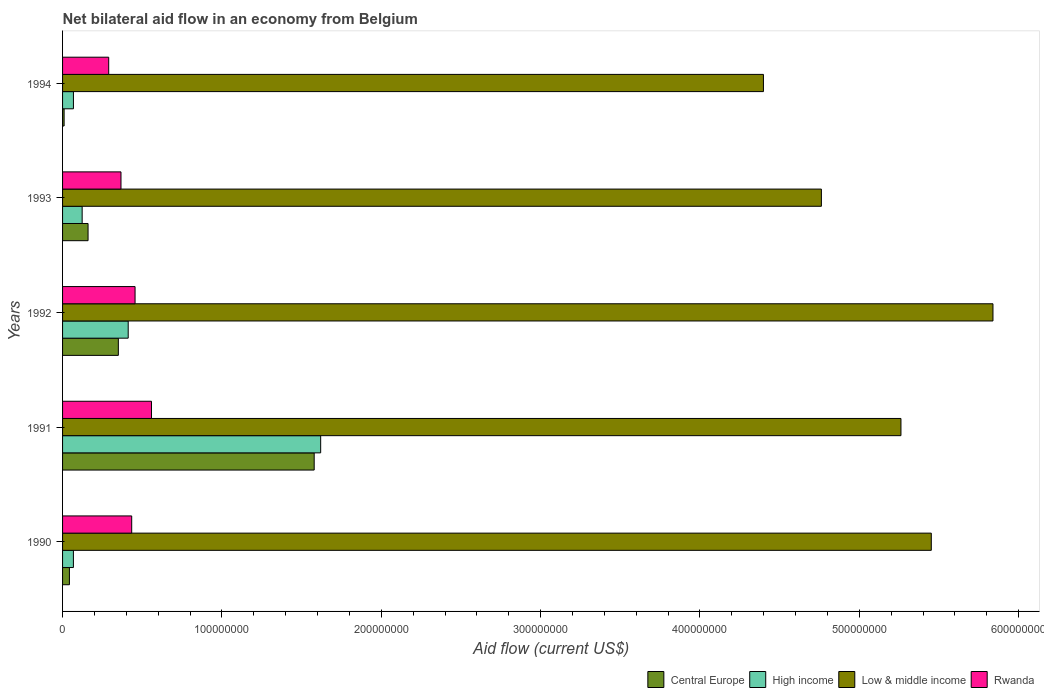How many different coloured bars are there?
Your answer should be very brief. 4. How many groups of bars are there?
Provide a short and direct response. 5. Are the number of bars on each tick of the Y-axis equal?
Your answer should be very brief. Yes. In how many cases, is the number of bars for a given year not equal to the number of legend labels?
Ensure brevity in your answer.  0. What is the net bilateral aid flow in Central Europe in 1990?
Your answer should be compact. 4.30e+06. Across all years, what is the maximum net bilateral aid flow in Rwanda?
Make the answer very short. 5.58e+07. Across all years, what is the minimum net bilateral aid flow in High income?
Provide a succinct answer. 6.80e+06. In which year was the net bilateral aid flow in High income maximum?
Offer a very short reply. 1991. In which year was the net bilateral aid flow in High income minimum?
Provide a succinct answer. 1990. What is the total net bilateral aid flow in Low & middle income in the graph?
Give a very brief answer. 2.57e+09. What is the difference between the net bilateral aid flow in Rwanda in 1991 and that in 1992?
Offer a terse response. 1.03e+07. What is the difference between the net bilateral aid flow in Low & middle income in 1990 and the net bilateral aid flow in Central Europe in 1992?
Provide a succinct answer. 5.10e+08. What is the average net bilateral aid flow in High income per year?
Your answer should be compact. 4.58e+07. In the year 1991, what is the difference between the net bilateral aid flow in High income and net bilateral aid flow in Central Europe?
Your response must be concise. 4.07e+06. In how many years, is the net bilateral aid flow in High income greater than 60000000 US$?
Provide a short and direct response. 1. What is the ratio of the net bilateral aid flow in Central Europe in 1991 to that in 1992?
Offer a terse response. 4.51. Is the net bilateral aid flow in Low & middle income in 1990 less than that in 1993?
Offer a terse response. No. What is the difference between the highest and the second highest net bilateral aid flow in Low & middle income?
Offer a terse response. 3.87e+07. What is the difference between the highest and the lowest net bilateral aid flow in Rwanda?
Ensure brevity in your answer.  2.68e+07. Is the sum of the net bilateral aid flow in High income in 1991 and 1993 greater than the maximum net bilateral aid flow in Rwanda across all years?
Keep it short and to the point. Yes. What does the 1st bar from the bottom in 1991 represents?
Provide a succinct answer. Central Europe. How many bars are there?
Provide a short and direct response. 20. Are all the bars in the graph horizontal?
Provide a succinct answer. Yes. How many years are there in the graph?
Your response must be concise. 5. What is the difference between two consecutive major ticks on the X-axis?
Ensure brevity in your answer.  1.00e+08. Does the graph contain grids?
Ensure brevity in your answer.  No. Where does the legend appear in the graph?
Your answer should be very brief. Bottom right. What is the title of the graph?
Your answer should be very brief. Net bilateral aid flow in an economy from Belgium. What is the label or title of the X-axis?
Your response must be concise. Aid flow (current US$). What is the label or title of the Y-axis?
Give a very brief answer. Years. What is the Aid flow (current US$) of Central Europe in 1990?
Ensure brevity in your answer.  4.30e+06. What is the Aid flow (current US$) in High income in 1990?
Your answer should be very brief. 6.80e+06. What is the Aid flow (current US$) in Low & middle income in 1990?
Your response must be concise. 5.45e+08. What is the Aid flow (current US$) in Rwanda in 1990?
Your response must be concise. 4.34e+07. What is the Aid flow (current US$) of Central Europe in 1991?
Ensure brevity in your answer.  1.58e+08. What is the Aid flow (current US$) of High income in 1991?
Give a very brief answer. 1.62e+08. What is the Aid flow (current US$) of Low & middle income in 1991?
Your response must be concise. 5.26e+08. What is the Aid flow (current US$) in Rwanda in 1991?
Provide a succinct answer. 5.58e+07. What is the Aid flow (current US$) of Central Europe in 1992?
Offer a very short reply. 3.50e+07. What is the Aid flow (current US$) in High income in 1992?
Ensure brevity in your answer.  4.12e+07. What is the Aid flow (current US$) of Low & middle income in 1992?
Offer a terse response. 5.84e+08. What is the Aid flow (current US$) of Rwanda in 1992?
Offer a very short reply. 4.55e+07. What is the Aid flow (current US$) in Central Europe in 1993?
Keep it short and to the point. 1.60e+07. What is the Aid flow (current US$) in High income in 1993?
Your answer should be very brief. 1.23e+07. What is the Aid flow (current US$) of Low & middle income in 1993?
Ensure brevity in your answer.  4.76e+08. What is the Aid flow (current US$) of Rwanda in 1993?
Offer a very short reply. 3.67e+07. What is the Aid flow (current US$) of Central Europe in 1994?
Your response must be concise. 9.70e+05. What is the Aid flow (current US$) in High income in 1994?
Provide a short and direct response. 6.82e+06. What is the Aid flow (current US$) of Low & middle income in 1994?
Keep it short and to the point. 4.40e+08. What is the Aid flow (current US$) of Rwanda in 1994?
Your answer should be very brief. 2.90e+07. Across all years, what is the maximum Aid flow (current US$) in Central Europe?
Keep it short and to the point. 1.58e+08. Across all years, what is the maximum Aid flow (current US$) in High income?
Give a very brief answer. 1.62e+08. Across all years, what is the maximum Aid flow (current US$) of Low & middle income?
Provide a short and direct response. 5.84e+08. Across all years, what is the maximum Aid flow (current US$) of Rwanda?
Your response must be concise. 5.58e+07. Across all years, what is the minimum Aid flow (current US$) in Central Europe?
Offer a very short reply. 9.70e+05. Across all years, what is the minimum Aid flow (current US$) of High income?
Give a very brief answer. 6.80e+06. Across all years, what is the minimum Aid flow (current US$) in Low & middle income?
Give a very brief answer. 4.40e+08. Across all years, what is the minimum Aid flow (current US$) in Rwanda?
Your answer should be compact. 2.90e+07. What is the total Aid flow (current US$) in Central Europe in the graph?
Keep it short and to the point. 2.14e+08. What is the total Aid flow (current US$) of High income in the graph?
Ensure brevity in your answer.  2.29e+08. What is the total Aid flow (current US$) of Low & middle income in the graph?
Ensure brevity in your answer.  2.57e+09. What is the total Aid flow (current US$) of Rwanda in the graph?
Provide a succinct answer. 2.10e+08. What is the difference between the Aid flow (current US$) of Central Europe in 1990 and that in 1991?
Your answer should be very brief. -1.54e+08. What is the difference between the Aid flow (current US$) of High income in 1990 and that in 1991?
Your answer should be very brief. -1.55e+08. What is the difference between the Aid flow (current US$) of Low & middle income in 1990 and that in 1991?
Make the answer very short. 1.90e+07. What is the difference between the Aid flow (current US$) in Rwanda in 1990 and that in 1991?
Provide a short and direct response. -1.24e+07. What is the difference between the Aid flow (current US$) of Central Europe in 1990 and that in 1992?
Give a very brief answer. -3.07e+07. What is the difference between the Aid flow (current US$) of High income in 1990 and that in 1992?
Your answer should be compact. -3.44e+07. What is the difference between the Aid flow (current US$) in Low & middle income in 1990 and that in 1992?
Your answer should be compact. -3.87e+07. What is the difference between the Aid flow (current US$) of Rwanda in 1990 and that in 1992?
Your answer should be very brief. -2.10e+06. What is the difference between the Aid flow (current US$) in Central Europe in 1990 and that in 1993?
Offer a very short reply. -1.17e+07. What is the difference between the Aid flow (current US$) in High income in 1990 and that in 1993?
Your answer should be compact. -5.49e+06. What is the difference between the Aid flow (current US$) of Low & middle income in 1990 and that in 1993?
Provide a short and direct response. 6.90e+07. What is the difference between the Aid flow (current US$) of Rwanda in 1990 and that in 1993?
Make the answer very short. 6.73e+06. What is the difference between the Aid flow (current US$) of Central Europe in 1990 and that in 1994?
Your answer should be compact. 3.33e+06. What is the difference between the Aid flow (current US$) in Low & middle income in 1990 and that in 1994?
Ensure brevity in your answer.  1.05e+08. What is the difference between the Aid flow (current US$) of Rwanda in 1990 and that in 1994?
Offer a terse response. 1.44e+07. What is the difference between the Aid flow (current US$) of Central Europe in 1991 and that in 1992?
Your response must be concise. 1.23e+08. What is the difference between the Aid flow (current US$) in High income in 1991 and that in 1992?
Offer a very short reply. 1.21e+08. What is the difference between the Aid flow (current US$) of Low & middle income in 1991 and that in 1992?
Offer a very short reply. -5.78e+07. What is the difference between the Aid flow (current US$) in Rwanda in 1991 and that in 1992?
Ensure brevity in your answer.  1.03e+07. What is the difference between the Aid flow (current US$) of Central Europe in 1991 and that in 1993?
Offer a terse response. 1.42e+08. What is the difference between the Aid flow (current US$) in High income in 1991 and that in 1993?
Give a very brief answer. 1.50e+08. What is the difference between the Aid flow (current US$) in Low & middle income in 1991 and that in 1993?
Provide a succinct answer. 4.99e+07. What is the difference between the Aid flow (current US$) in Rwanda in 1991 and that in 1993?
Your response must be concise. 1.91e+07. What is the difference between the Aid flow (current US$) of Central Europe in 1991 and that in 1994?
Offer a terse response. 1.57e+08. What is the difference between the Aid flow (current US$) of High income in 1991 and that in 1994?
Make the answer very short. 1.55e+08. What is the difference between the Aid flow (current US$) in Low & middle income in 1991 and that in 1994?
Offer a terse response. 8.63e+07. What is the difference between the Aid flow (current US$) in Rwanda in 1991 and that in 1994?
Give a very brief answer. 2.68e+07. What is the difference between the Aid flow (current US$) of Central Europe in 1992 and that in 1993?
Keep it short and to the point. 1.90e+07. What is the difference between the Aid flow (current US$) of High income in 1992 and that in 1993?
Ensure brevity in your answer.  2.89e+07. What is the difference between the Aid flow (current US$) in Low & middle income in 1992 and that in 1993?
Your response must be concise. 1.08e+08. What is the difference between the Aid flow (current US$) in Rwanda in 1992 and that in 1993?
Offer a very short reply. 8.83e+06. What is the difference between the Aid flow (current US$) of Central Europe in 1992 and that in 1994?
Make the answer very short. 3.40e+07. What is the difference between the Aid flow (current US$) in High income in 1992 and that in 1994?
Your answer should be very brief. 3.44e+07. What is the difference between the Aid flow (current US$) of Low & middle income in 1992 and that in 1994?
Provide a short and direct response. 1.44e+08. What is the difference between the Aid flow (current US$) in Rwanda in 1992 and that in 1994?
Your answer should be very brief. 1.65e+07. What is the difference between the Aid flow (current US$) in Central Europe in 1993 and that in 1994?
Keep it short and to the point. 1.50e+07. What is the difference between the Aid flow (current US$) of High income in 1993 and that in 1994?
Your answer should be compact. 5.47e+06. What is the difference between the Aid flow (current US$) of Low & middle income in 1993 and that in 1994?
Your answer should be compact. 3.64e+07. What is the difference between the Aid flow (current US$) of Rwanda in 1993 and that in 1994?
Offer a very short reply. 7.71e+06. What is the difference between the Aid flow (current US$) in Central Europe in 1990 and the Aid flow (current US$) in High income in 1991?
Your response must be concise. -1.58e+08. What is the difference between the Aid flow (current US$) in Central Europe in 1990 and the Aid flow (current US$) in Low & middle income in 1991?
Your answer should be compact. -5.22e+08. What is the difference between the Aid flow (current US$) of Central Europe in 1990 and the Aid flow (current US$) of Rwanda in 1991?
Make the answer very short. -5.15e+07. What is the difference between the Aid flow (current US$) of High income in 1990 and the Aid flow (current US$) of Low & middle income in 1991?
Offer a terse response. -5.19e+08. What is the difference between the Aid flow (current US$) in High income in 1990 and the Aid flow (current US$) in Rwanda in 1991?
Provide a short and direct response. -4.90e+07. What is the difference between the Aid flow (current US$) in Low & middle income in 1990 and the Aid flow (current US$) in Rwanda in 1991?
Offer a very short reply. 4.89e+08. What is the difference between the Aid flow (current US$) of Central Europe in 1990 and the Aid flow (current US$) of High income in 1992?
Offer a very short reply. -3.69e+07. What is the difference between the Aid flow (current US$) in Central Europe in 1990 and the Aid flow (current US$) in Low & middle income in 1992?
Your answer should be very brief. -5.80e+08. What is the difference between the Aid flow (current US$) of Central Europe in 1990 and the Aid flow (current US$) of Rwanda in 1992?
Keep it short and to the point. -4.12e+07. What is the difference between the Aid flow (current US$) of High income in 1990 and the Aid flow (current US$) of Low & middle income in 1992?
Your response must be concise. -5.77e+08. What is the difference between the Aid flow (current US$) of High income in 1990 and the Aid flow (current US$) of Rwanda in 1992?
Provide a short and direct response. -3.87e+07. What is the difference between the Aid flow (current US$) of Low & middle income in 1990 and the Aid flow (current US$) of Rwanda in 1992?
Provide a short and direct response. 5.00e+08. What is the difference between the Aid flow (current US$) of Central Europe in 1990 and the Aid flow (current US$) of High income in 1993?
Provide a succinct answer. -7.99e+06. What is the difference between the Aid flow (current US$) in Central Europe in 1990 and the Aid flow (current US$) in Low & middle income in 1993?
Give a very brief answer. -4.72e+08. What is the difference between the Aid flow (current US$) of Central Europe in 1990 and the Aid flow (current US$) of Rwanda in 1993?
Provide a short and direct response. -3.24e+07. What is the difference between the Aid flow (current US$) in High income in 1990 and the Aid flow (current US$) in Low & middle income in 1993?
Provide a short and direct response. -4.69e+08. What is the difference between the Aid flow (current US$) in High income in 1990 and the Aid flow (current US$) in Rwanda in 1993?
Keep it short and to the point. -2.99e+07. What is the difference between the Aid flow (current US$) of Low & middle income in 1990 and the Aid flow (current US$) of Rwanda in 1993?
Your answer should be compact. 5.09e+08. What is the difference between the Aid flow (current US$) of Central Europe in 1990 and the Aid flow (current US$) of High income in 1994?
Provide a succinct answer. -2.52e+06. What is the difference between the Aid flow (current US$) in Central Europe in 1990 and the Aid flow (current US$) in Low & middle income in 1994?
Your answer should be very brief. -4.36e+08. What is the difference between the Aid flow (current US$) of Central Europe in 1990 and the Aid flow (current US$) of Rwanda in 1994?
Offer a terse response. -2.46e+07. What is the difference between the Aid flow (current US$) of High income in 1990 and the Aid flow (current US$) of Low & middle income in 1994?
Offer a terse response. -4.33e+08. What is the difference between the Aid flow (current US$) of High income in 1990 and the Aid flow (current US$) of Rwanda in 1994?
Offer a terse response. -2.22e+07. What is the difference between the Aid flow (current US$) in Low & middle income in 1990 and the Aid flow (current US$) in Rwanda in 1994?
Keep it short and to the point. 5.16e+08. What is the difference between the Aid flow (current US$) of Central Europe in 1991 and the Aid flow (current US$) of High income in 1992?
Your response must be concise. 1.17e+08. What is the difference between the Aid flow (current US$) of Central Europe in 1991 and the Aid flow (current US$) of Low & middle income in 1992?
Provide a succinct answer. -4.26e+08. What is the difference between the Aid flow (current US$) in Central Europe in 1991 and the Aid flow (current US$) in Rwanda in 1992?
Your answer should be very brief. 1.12e+08. What is the difference between the Aid flow (current US$) of High income in 1991 and the Aid flow (current US$) of Low & middle income in 1992?
Make the answer very short. -4.22e+08. What is the difference between the Aid flow (current US$) in High income in 1991 and the Aid flow (current US$) in Rwanda in 1992?
Your answer should be very brief. 1.16e+08. What is the difference between the Aid flow (current US$) of Low & middle income in 1991 and the Aid flow (current US$) of Rwanda in 1992?
Your answer should be very brief. 4.81e+08. What is the difference between the Aid flow (current US$) of Central Europe in 1991 and the Aid flow (current US$) of High income in 1993?
Keep it short and to the point. 1.46e+08. What is the difference between the Aid flow (current US$) of Central Europe in 1991 and the Aid flow (current US$) of Low & middle income in 1993?
Provide a succinct answer. -3.18e+08. What is the difference between the Aid flow (current US$) in Central Europe in 1991 and the Aid flow (current US$) in Rwanda in 1993?
Offer a very short reply. 1.21e+08. What is the difference between the Aid flow (current US$) in High income in 1991 and the Aid flow (current US$) in Low & middle income in 1993?
Ensure brevity in your answer.  -3.14e+08. What is the difference between the Aid flow (current US$) of High income in 1991 and the Aid flow (current US$) of Rwanda in 1993?
Offer a terse response. 1.25e+08. What is the difference between the Aid flow (current US$) in Low & middle income in 1991 and the Aid flow (current US$) in Rwanda in 1993?
Give a very brief answer. 4.89e+08. What is the difference between the Aid flow (current US$) in Central Europe in 1991 and the Aid flow (current US$) in High income in 1994?
Offer a terse response. 1.51e+08. What is the difference between the Aid flow (current US$) in Central Europe in 1991 and the Aid flow (current US$) in Low & middle income in 1994?
Provide a succinct answer. -2.82e+08. What is the difference between the Aid flow (current US$) in Central Europe in 1991 and the Aid flow (current US$) in Rwanda in 1994?
Provide a succinct answer. 1.29e+08. What is the difference between the Aid flow (current US$) of High income in 1991 and the Aid flow (current US$) of Low & middle income in 1994?
Make the answer very short. -2.78e+08. What is the difference between the Aid flow (current US$) in High income in 1991 and the Aid flow (current US$) in Rwanda in 1994?
Make the answer very short. 1.33e+08. What is the difference between the Aid flow (current US$) of Low & middle income in 1991 and the Aid flow (current US$) of Rwanda in 1994?
Your answer should be very brief. 4.97e+08. What is the difference between the Aid flow (current US$) of Central Europe in 1992 and the Aid flow (current US$) of High income in 1993?
Ensure brevity in your answer.  2.27e+07. What is the difference between the Aid flow (current US$) in Central Europe in 1992 and the Aid flow (current US$) in Low & middle income in 1993?
Make the answer very short. -4.41e+08. What is the difference between the Aid flow (current US$) in Central Europe in 1992 and the Aid flow (current US$) in Rwanda in 1993?
Provide a succinct answer. -1.66e+06. What is the difference between the Aid flow (current US$) of High income in 1992 and the Aid flow (current US$) of Low & middle income in 1993?
Your response must be concise. -4.35e+08. What is the difference between the Aid flow (current US$) in High income in 1992 and the Aid flow (current US$) in Rwanda in 1993?
Keep it short and to the point. 4.53e+06. What is the difference between the Aid flow (current US$) in Low & middle income in 1992 and the Aid flow (current US$) in Rwanda in 1993?
Keep it short and to the point. 5.47e+08. What is the difference between the Aid flow (current US$) of Central Europe in 1992 and the Aid flow (current US$) of High income in 1994?
Keep it short and to the point. 2.82e+07. What is the difference between the Aid flow (current US$) in Central Europe in 1992 and the Aid flow (current US$) in Low & middle income in 1994?
Your answer should be compact. -4.05e+08. What is the difference between the Aid flow (current US$) in Central Europe in 1992 and the Aid flow (current US$) in Rwanda in 1994?
Your answer should be compact. 6.05e+06. What is the difference between the Aid flow (current US$) of High income in 1992 and the Aid flow (current US$) of Low & middle income in 1994?
Provide a succinct answer. -3.99e+08. What is the difference between the Aid flow (current US$) in High income in 1992 and the Aid flow (current US$) in Rwanda in 1994?
Your answer should be very brief. 1.22e+07. What is the difference between the Aid flow (current US$) of Low & middle income in 1992 and the Aid flow (current US$) of Rwanda in 1994?
Ensure brevity in your answer.  5.55e+08. What is the difference between the Aid flow (current US$) in Central Europe in 1993 and the Aid flow (current US$) in High income in 1994?
Keep it short and to the point. 9.18e+06. What is the difference between the Aid flow (current US$) of Central Europe in 1993 and the Aid flow (current US$) of Low & middle income in 1994?
Offer a terse response. -4.24e+08. What is the difference between the Aid flow (current US$) of Central Europe in 1993 and the Aid flow (current US$) of Rwanda in 1994?
Keep it short and to the point. -1.30e+07. What is the difference between the Aid flow (current US$) in High income in 1993 and the Aid flow (current US$) in Low & middle income in 1994?
Give a very brief answer. -4.28e+08. What is the difference between the Aid flow (current US$) of High income in 1993 and the Aid flow (current US$) of Rwanda in 1994?
Provide a succinct answer. -1.67e+07. What is the difference between the Aid flow (current US$) in Low & middle income in 1993 and the Aid flow (current US$) in Rwanda in 1994?
Your answer should be very brief. 4.47e+08. What is the average Aid flow (current US$) in Central Europe per year?
Provide a short and direct response. 4.28e+07. What is the average Aid flow (current US$) of High income per year?
Offer a terse response. 4.58e+07. What is the average Aid flow (current US$) in Low & middle income per year?
Keep it short and to the point. 5.14e+08. What is the average Aid flow (current US$) in Rwanda per year?
Keep it short and to the point. 4.21e+07. In the year 1990, what is the difference between the Aid flow (current US$) of Central Europe and Aid flow (current US$) of High income?
Ensure brevity in your answer.  -2.50e+06. In the year 1990, what is the difference between the Aid flow (current US$) of Central Europe and Aid flow (current US$) of Low & middle income?
Your answer should be compact. -5.41e+08. In the year 1990, what is the difference between the Aid flow (current US$) in Central Europe and Aid flow (current US$) in Rwanda?
Provide a short and direct response. -3.91e+07. In the year 1990, what is the difference between the Aid flow (current US$) in High income and Aid flow (current US$) in Low & middle income?
Give a very brief answer. -5.38e+08. In the year 1990, what is the difference between the Aid flow (current US$) of High income and Aid flow (current US$) of Rwanda?
Offer a very short reply. -3.66e+07. In the year 1990, what is the difference between the Aid flow (current US$) of Low & middle income and Aid flow (current US$) of Rwanda?
Keep it short and to the point. 5.02e+08. In the year 1991, what is the difference between the Aid flow (current US$) of Central Europe and Aid flow (current US$) of High income?
Make the answer very short. -4.07e+06. In the year 1991, what is the difference between the Aid flow (current US$) in Central Europe and Aid flow (current US$) in Low & middle income?
Provide a succinct answer. -3.68e+08. In the year 1991, what is the difference between the Aid flow (current US$) of Central Europe and Aid flow (current US$) of Rwanda?
Your answer should be compact. 1.02e+08. In the year 1991, what is the difference between the Aid flow (current US$) in High income and Aid flow (current US$) in Low & middle income?
Keep it short and to the point. -3.64e+08. In the year 1991, what is the difference between the Aid flow (current US$) of High income and Aid flow (current US$) of Rwanda?
Your answer should be very brief. 1.06e+08. In the year 1991, what is the difference between the Aid flow (current US$) in Low & middle income and Aid flow (current US$) in Rwanda?
Provide a succinct answer. 4.70e+08. In the year 1992, what is the difference between the Aid flow (current US$) in Central Europe and Aid flow (current US$) in High income?
Your answer should be very brief. -6.19e+06. In the year 1992, what is the difference between the Aid flow (current US$) in Central Europe and Aid flow (current US$) in Low & middle income?
Offer a terse response. -5.49e+08. In the year 1992, what is the difference between the Aid flow (current US$) of Central Europe and Aid flow (current US$) of Rwanda?
Your answer should be very brief. -1.05e+07. In the year 1992, what is the difference between the Aid flow (current US$) of High income and Aid flow (current US$) of Low & middle income?
Make the answer very short. -5.43e+08. In the year 1992, what is the difference between the Aid flow (current US$) in High income and Aid flow (current US$) in Rwanda?
Your response must be concise. -4.30e+06. In the year 1992, what is the difference between the Aid flow (current US$) of Low & middle income and Aid flow (current US$) of Rwanda?
Provide a short and direct response. 5.38e+08. In the year 1993, what is the difference between the Aid flow (current US$) in Central Europe and Aid flow (current US$) in High income?
Ensure brevity in your answer.  3.71e+06. In the year 1993, what is the difference between the Aid flow (current US$) of Central Europe and Aid flow (current US$) of Low & middle income?
Ensure brevity in your answer.  -4.60e+08. In the year 1993, what is the difference between the Aid flow (current US$) of Central Europe and Aid flow (current US$) of Rwanda?
Your answer should be compact. -2.07e+07. In the year 1993, what is the difference between the Aid flow (current US$) of High income and Aid flow (current US$) of Low & middle income?
Provide a succinct answer. -4.64e+08. In the year 1993, what is the difference between the Aid flow (current US$) of High income and Aid flow (current US$) of Rwanda?
Ensure brevity in your answer.  -2.44e+07. In the year 1993, what is the difference between the Aid flow (current US$) of Low & middle income and Aid flow (current US$) of Rwanda?
Offer a terse response. 4.40e+08. In the year 1994, what is the difference between the Aid flow (current US$) in Central Europe and Aid flow (current US$) in High income?
Keep it short and to the point. -5.85e+06. In the year 1994, what is the difference between the Aid flow (current US$) of Central Europe and Aid flow (current US$) of Low & middle income?
Your answer should be very brief. -4.39e+08. In the year 1994, what is the difference between the Aid flow (current US$) of Central Europe and Aid flow (current US$) of Rwanda?
Offer a very short reply. -2.80e+07. In the year 1994, what is the difference between the Aid flow (current US$) in High income and Aid flow (current US$) in Low & middle income?
Your response must be concise. -4.33e+08. In the year 1994, what is the difference between the Aid flow (current US$) in High income and Aid flow (current US$) in Rwanda?
Keep it short and to the point. -2.21e+07. In the year 1994, what is the difference between the Aid flow (current US$) of Low & middle income and Aid flow (current US$) of Rwanda?
Give a very brief answer. 4.11e+08. What is the ratio of the Aid flow (current US$) of Central Europe in 1990 to that in 1991?
Your answer should be very brief. 0.03. What is the ratio of the Aid flow (current US$) in High income in 1990 to that in 1991?
Your response must be concise. 0.04. What is the ratio of the Aid flow (current US$) of Low & middle income in 1990 to that in 1991?
Your answer should be very brief. 1.04. What is the ratio of the Aid flow (current US$) in Rwanda in 1990 to that in 1991?
Keep it short and to the point. 0.78. What is the ratio of the Aid flow (current US$) of Central Europe in 1990 to that in 1992?
Provide a succinct answer. 0.12. What is the ratio of the Aid flow (current US$) of High income in 1990 to that in 1992?
Give a very brief answer. 0.17. What is the ratio of the Aid flow (current US$) of Low & middle income in 1990 to that in 1992?
Offer a terse response. 0.93. What is the ratio of the Aid flow (current US$) of Rwanda in 1990 to that in 1992?
Provide a short and direct response. 0.95. What is the ratio of the Aid flow (current US$) in Central Europe in 1990 to that in 1993?
Provide a succinct answer. 0.27. What is the ratio of the Aid flow (current US$) in High income in 1990 to that in 1993?
Give a very brief answer. 0.55. What is the ratio of the Aid flow (current US$) of Low & middle income in 1990 to that in 1993?
Your answer should be very brief. 1.14. What is the ratio of the Aid flow (current US$) in Rwanda in 1990 to that in 1993?
Your answer should be very brief. 1.18. What is the ratio of the Aid flow (current US$) of Central Europe in 1990 to that in 1994?
Keep it short and to the point. 4.43. What is the ratio of the Aid flow (current US$) in Low & middle income in 1990 to that in 1994?
Offer a very short reply. 1.24. What is the ratio of the Aid flow (current US$) in Rwanda in 1990 to that in 1994?
Keep it short and to the point. 1.5. What is the ratio of the Aid flow (current US$) of Central Europe in 1991 to that in 1992?
Offer a terse response. 4.51. What is the ratio of the Aid flow (current US$) of High income in 1991 to that in 1992?
Provide a short and direct response. 3.93. What is the ratio of the Aid flow (current US$) of Low & middle income in 1991 to that in 1992?
Offer a terse response. 0.9. What is the ratio of the Aid flow (current US$) of Rwanda in 1991 to that in 1992?
Provide a succinct answer. 1.23. What is the ratio of the Aid flow (current US$) in Central Europe in 1991 to that in 1993?
Keep it short and to the point. 9.87. What is the ratio of the Aid flow (current US$) in High income in 1991 to that in 1993?
Provide a succinct answer. 13.18. What is the ratio of the Aid flow (current US$) of Low & middle income in 1991 to that in 1993?
Your response must be concise. 1.1. What is the ratio of the Aid flow (current US$) of Rwanda in 1991 to that in 1993?
Give a very brief answer. 1.52. What is the ratio of the Aid flow (current US$) of Central Europe in 1991 to that in 1994?
Provide a succinct answer. 162.78. What is the ratio of the Aid flow (current US$) of High income in 1991 to that in 1994?
Ensure brevity in your answer.  23.75. What is the ratio of the Aid flow (current US$) of Low & middle income in 1991 to that in 1994?
Provide a succinct answer. 1.2. What is the ratio of the Aid flow (current US$) of Rwanda in 1991 to that in 1994?
Your response must be concise. 1.93. What is the ratio of the Aid flow (current US$) of Central Europe in 1992 to that in 1993?
Make the answer very short. 2.19. What is the ratio of the Aid flow (current US$) of High income in 1992 to that in 1993?
Your answer should be very brief. 3.35. What is the ratio of the Aid flow (current US$) in Low & middle income in 1992 to that in 1993?
Provide a short and direct response. 1.23. What is the ratio of the Aid flow (current US$) in Rwanda in 1992 to that in 1993?
Provide a succinct answer. 1.24. What is the ratio of the Aid flow (current US$) of Central Europe in 1992 to that in 1994?
Give a very brief answer. 36.08. What is the ratio of the Aid flow (current US$) of High income in 1992 to that in 1994?
Provide a short and direct response. 6.04. What is the ratio of the Aid flow (current US$) of Low & middle income in 1992 to that in 1994?
Make the answer very short. 1.33. What is the ratio of the Aid flow (current US$) of Rwanda in 1992 to that in 1994?
Your answer should be compact. 1.57. What is the ratio of the Aid flow (current US$) in Central Europe in 1993 to that in 1994?
Offer a terse response. 16.49. What is the ratio of the Aid flow (current US$) in High income in 1993 to that in 1994?
Ensure brevity in your answer.  1.8. What is the ratio of the Aid flow (current US$) in Low & middle income in 1993 to that in 1994?
Make the answer very short. 1.08. What is the ratio of the Aid flow (current US$) in Rwanda in 1993 to that in 1994?
Give a very brief answer. 1.27. What is the difference between the highest and the second highest Aid flow (current US$) of Central Europe?
Provide a succinct answer. 1.23e+08. What is the difference between the highest and the second highest Aid flow (current US$) of High income?
Your answer should be very brief. 1.21e+08. What is the difference between the highest and the second highest Aid flow (current US$) of Low & middle income?
Keep it short and to the point. 3.87e+07. What is the difference between the highest and the second highest Aid flow (current US$) of Rwanda?
Ensure brevity in your answer.  1.03e+07. What is the difference between the highest and the lowest Aid flow (current US$) in Central Europe?
Provide a short and direct response. 1.57e+08. What is the difference between the highest and the lowest Aid flow (current US$) of High income?
Your answer should be very brief. 1.55e+08. What is the difference between the highest and the lowest Aid flow (current US$) of Low & middle income?
Your answer should be very brief. 1.44e+08. What is the difference between the highest and the lowest Aid flow (current US$) of Rwanda?
Ensure brevity in your answer.  2.68e+07. 